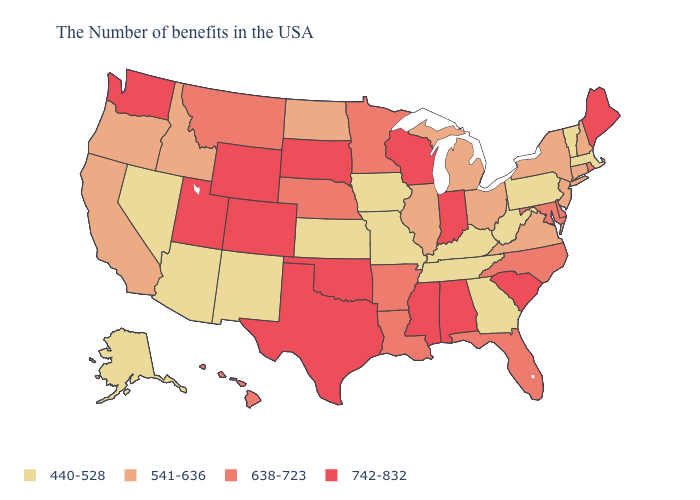What is the highest value in states that border Pennsylvania?
Write a very short answer. 638-723. Among the states that border Missouri , which have the highest value?
Keep it brief. Oklahoma. Does the map have missing data?
Be succinct. No. Which states have the lowest value in the MidWest?
Write a very short answer. Missouri, Iowa, Kansas. What is the lowest value in the USA?
Keep it brief. 440-528. Name the states that have a value in the range 541-636?
Answer briefly. New Hampshire, Connecticut, New York, New Jersey, Virginia, Ohio, Michigan, Illinois, North Dakota, Idaho, California, Oregon. What is the value of Utah?
Short answer required. 742-832. Is the legend a continuous bar?
Keep it brief. No. What is the value of North Carolina?
Be succinct. 638-723. Which states have the highest value in the USA?
Short answer required. Maine, South Carolina, Indiana, Alabama, Wisconsin, Mississippi, Oklahoma, Texas, South Dakota, Wyoming, Colorado, Utah, Washington. Which states have the highest value in the USA?
Be succinct. Maine, South Carolina, Indiana, Alabama, Wisconsin, Mississippi, Oklahoma, Texas, South Dakota, Wyoming, Colorado, Utah, Washington. Which states hav the highest value in the MidWest?
Concise answer only. Indiana, Wisconsin, South Dakota. What is the value of Massachusetts?
Write a very short answer. 440-528. What is the value of Maryland?
Be succinct. 638-723. What is the lowest value in the West?
Short answer required. 440-528. 